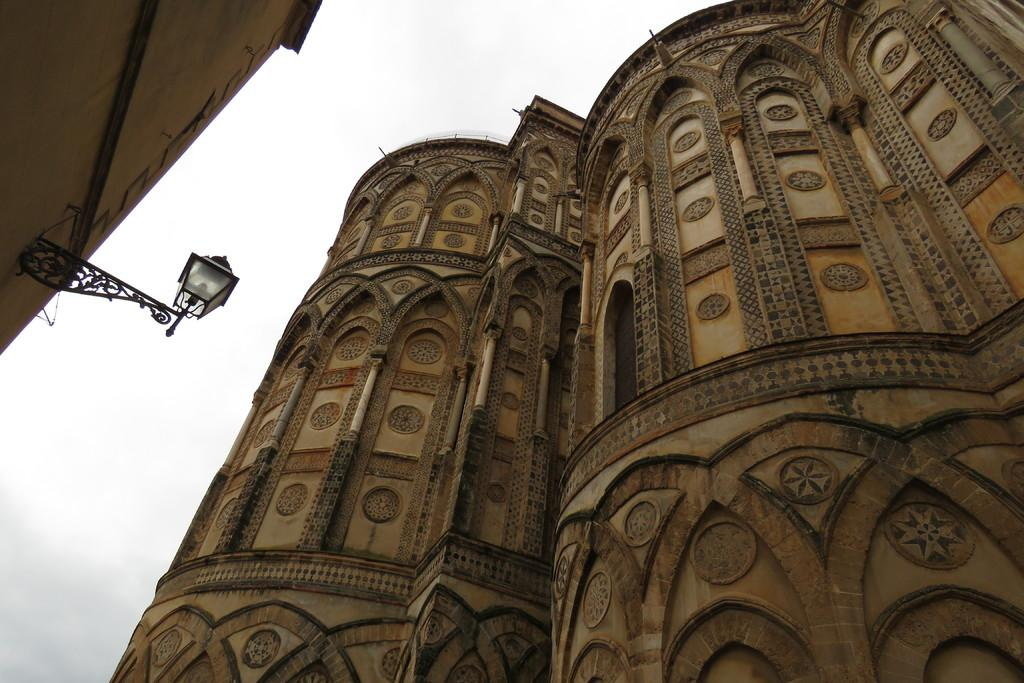What type of structure is in the image? There is a building or a castle in the image. Where is the street light located in the image? The street light is in the left top of the image. What else can be seen in the left top of the image? There is another building in the left top of the image. What can be seen in the background of the image? The sky is visible in the background of the image. What type of stick can be seen in the image? There is no stick present in the image. Is there a field visible in the image? No, there is no field visible in the image; it features a building or castle, a street light, another building, and the sky. 